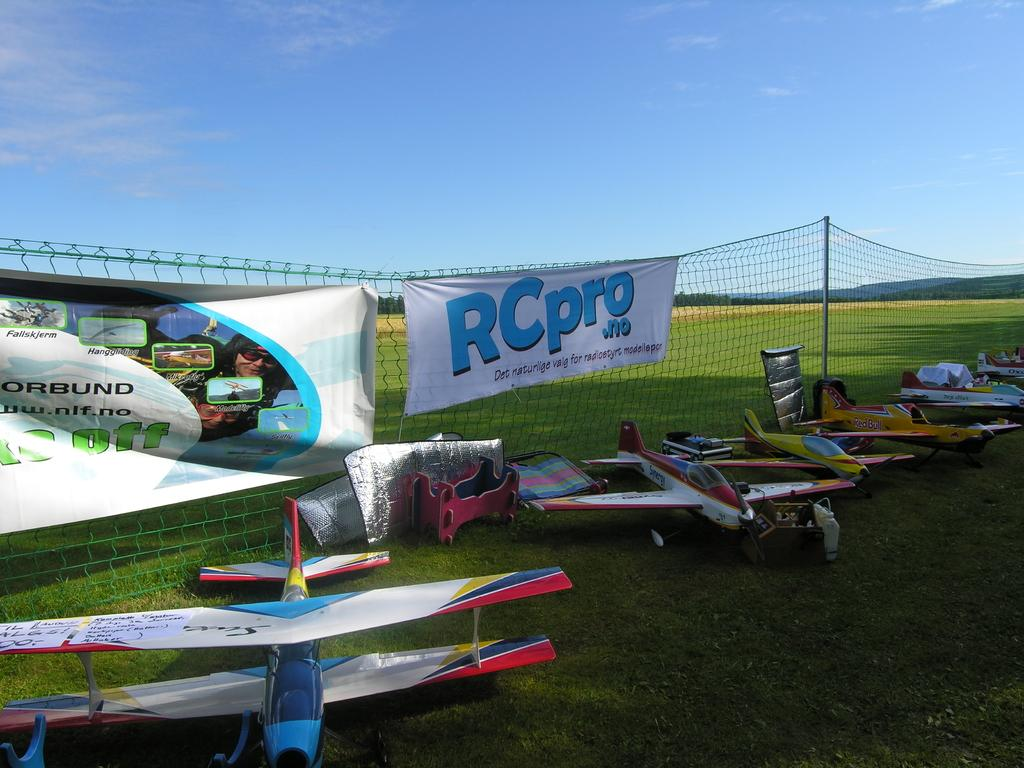Provide a one-sentence caption for the provided image. A white sign on a fence reads "RCpro". 